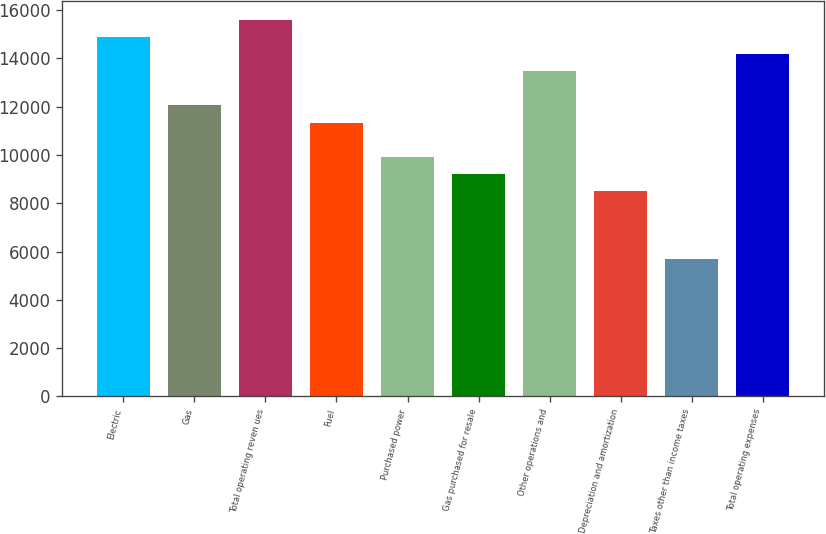Convert chart. <chart><loc_0><loc_0><loc_500><loc_500><bar_chart><fcel>Electric<fcel>Gas<fcel>Total operating reven ues<fcel>Fuel<fcel>Purchased power<fcel>Gas purchased for resale<fcel>Other operations and<fcel>Depreciation and amortization<fcel>Taxes other than income taxes<fcel>Total operating expenses<nl><fcel>14887.4<fcel>12052<fcel>15596.2<fcel>11343.1<fcel>9925.44<fcel>9216.59<fcel>13469.7<fcel>8507.74<fcel>5672.34<fcel>14178.5<nl></chart> 